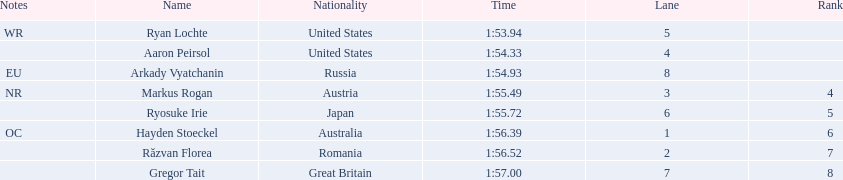Who are the swimmers? Ryan Lochte, Aaron Peirsol, Arkady Vyatchanin, Markus Rogan, Ryosuke Irie, Hayden Stoeckel, Răzvan Florea, Gregor Tait. What is ryosuke irie's time? 1:55.72. 